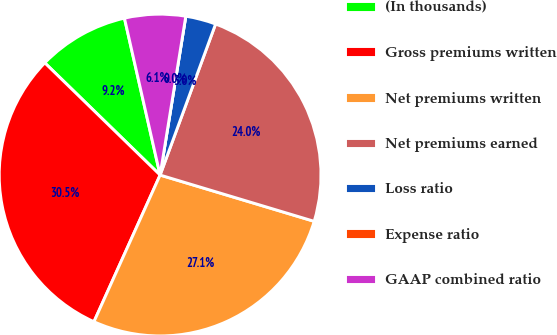Convert chart. <chart><loc_0><loc_0><loc_500><loc_500><pie_chart><fcel>(In thousands)<fcel>Gross premiums written<fcel>Net premiums written<fcel>Net premiums earned<fcel>Loss ratio<fcel>Expense ratio<fcel>GAAP combined ratio<nl><fcel>9.16%<fcel>30.54%<fcel>27.1%<fcel>24.04%<fcel>3.05%<fcel>0.0%<fcel>6.11%<nl></chart> 